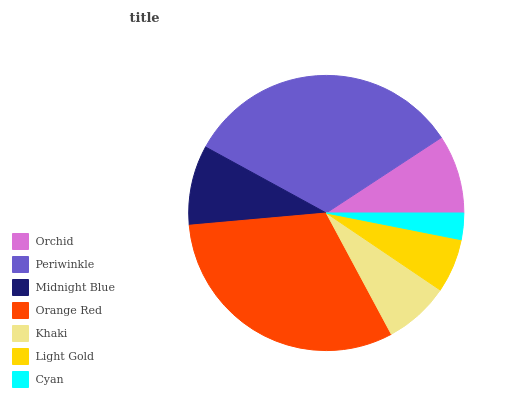Is Cyan the minimum?
Answer yes or no. Yes. Is Periwinkle the maximum?
Answer yes or no. Yes. Is Midnight Blue the minimum?
Answer yes or no. No. Is Midnight Blue the maximum?
Answer yes or no. No. Is Periwinkle greater than Midnight Blue?
Answer yes or no. Yes. Is Midnight Blue less than Periwinkle?
Answer yes or no. Yes. Is Midnight Blue greater than Periwinkle?
Answer yes or no. No. Is Periwinkle less than Midnight Blue?
Answer yes or no. No. Is Orchid the high median?
Answer yes or no. Yes. Is Orchid the low median?
Answer yes or no. Yes. Is Light Gold the high median?
Answer yes or no. No. Is Periwinkle the low median?
Answer yes or no. No. 